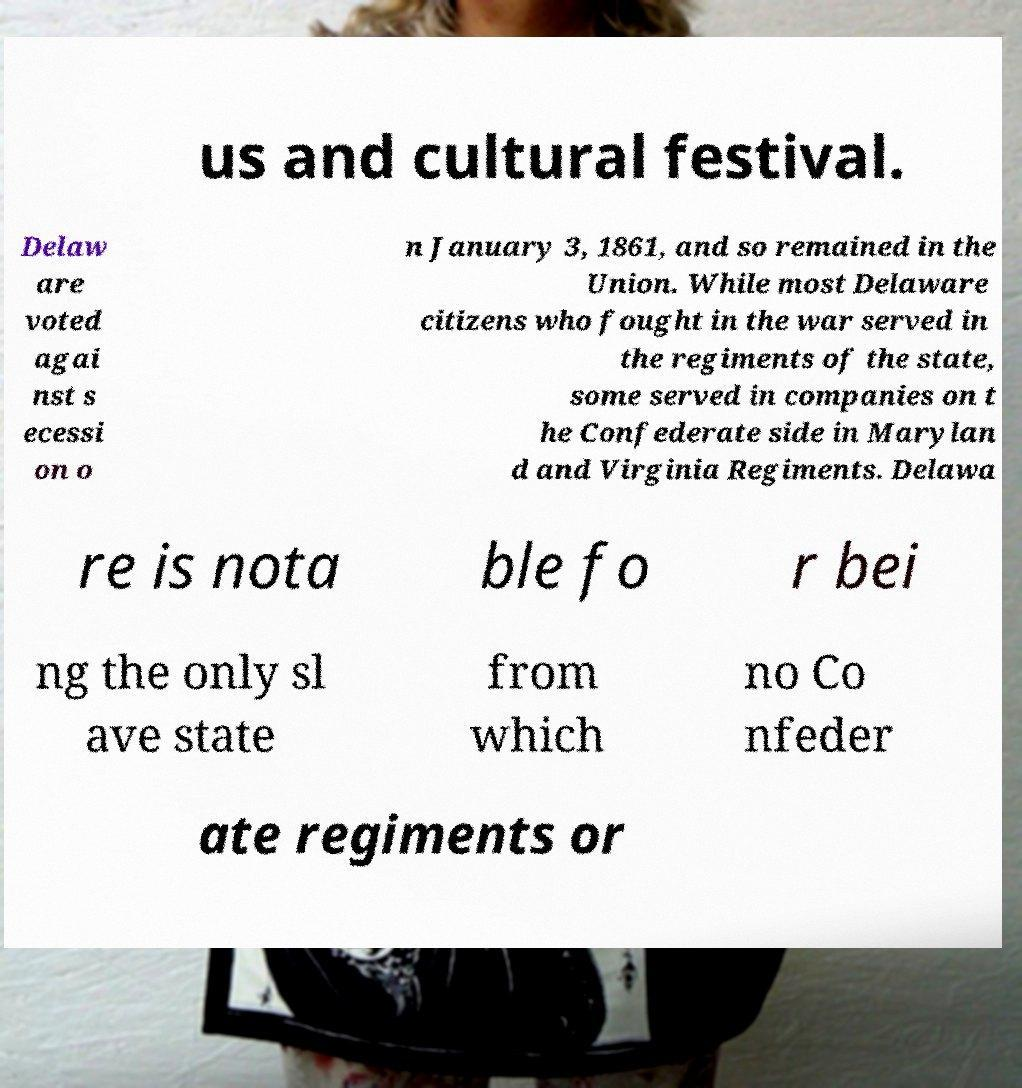Could you assist in decoding the text presented in this image and type it out clearly? us and cultural festival. Delaw are voted agai nst s ecessi on o n January 3, 1861, and so remained in the Union. While most Delaware citizens who fought in the war served in the regiments of the state, some served in companies on t he Confederate side in Marylan d and Virginia Regiments. Delawa re is nota ble fo r bei ng the only sl ave state from which no Co nfeder ate regiments or 